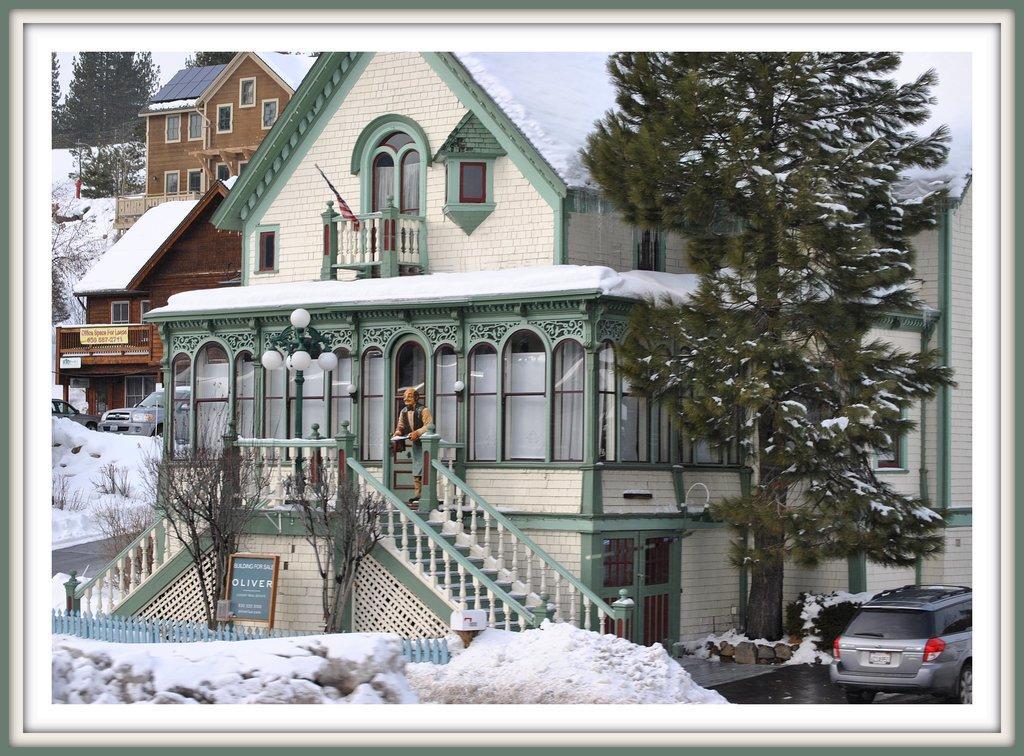Can you describe this image briefly? In this image I can see few buildings, windows, stairs, snow, trees, board, fencing, few vehicles and the toy person is standing. 